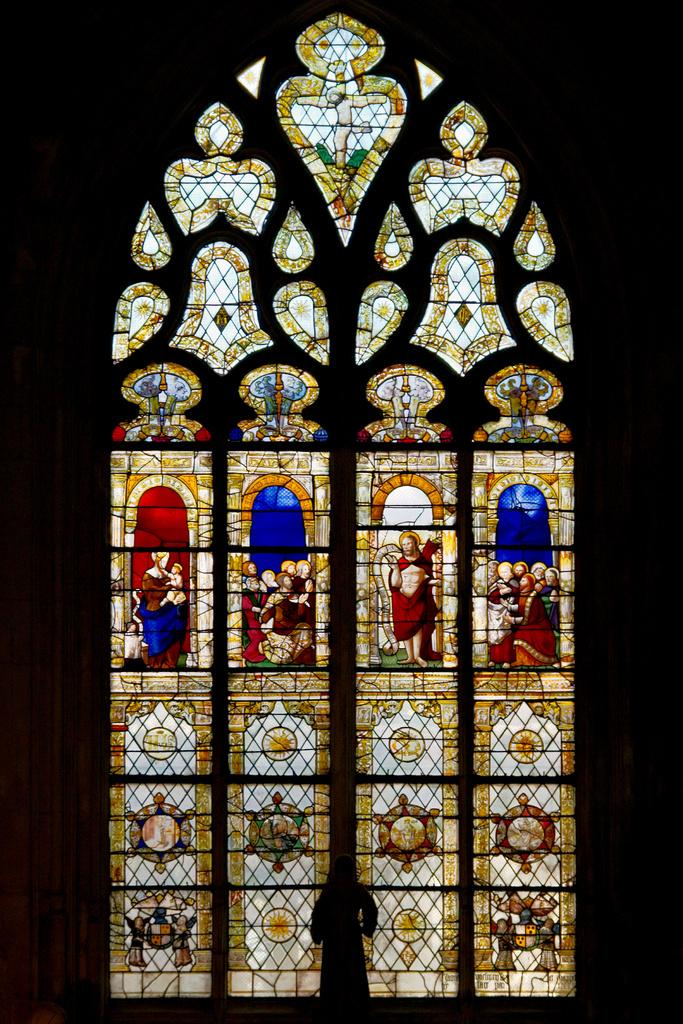What type of glass is featured in the image? There is a stained glass in the image. What color is the background of the image? The background of the image is black. How many parents are visible in the image? There are no parents present in the image; it features a stained glass with a black background. 